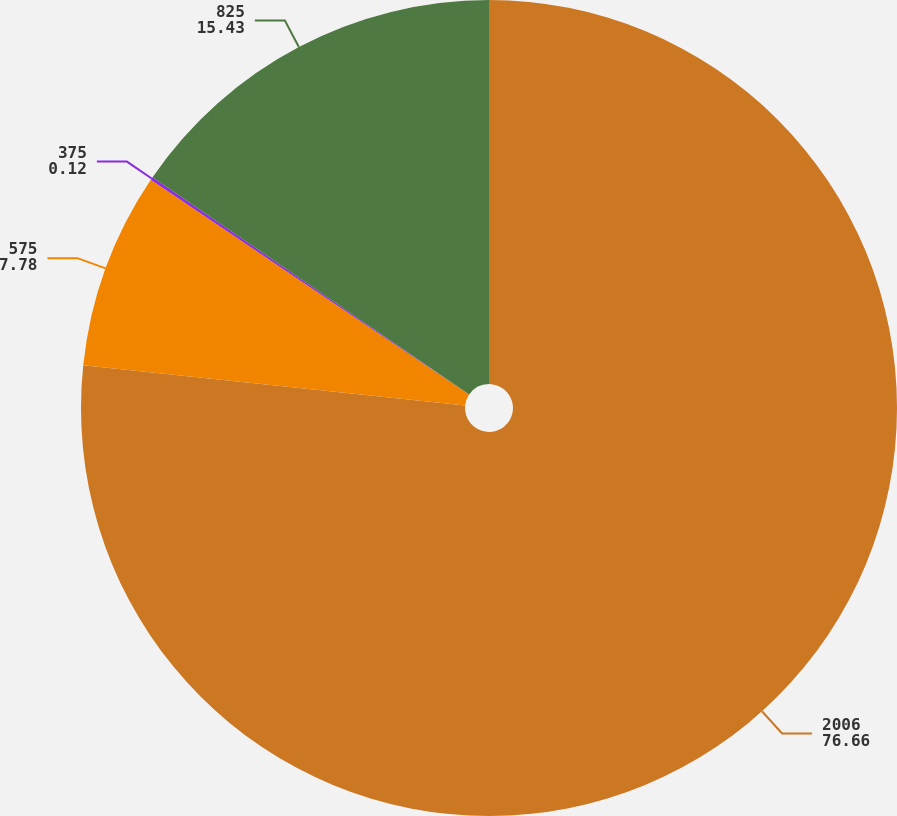Convert chart to OTSL. <chart><loc_0><loc_0><loc_500><loc_500><pie_chart><fcel>2006<fcel>575<fcel>375<fcel>825<nl><fcel>76.66%<fcel>7.78%<fcel>0.12%<fcel>15.43%<nl></chart> 